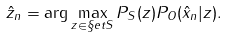Convert formula to latex. <formula><loc_0><loc_0><loc_500><loc_500>\hat { z } _ { n } = \arg \max _ { z \in \S e t S } P _ { S } ( z ) P _ { O } ( \hat { x } _ { n } | z ) .</formula> 